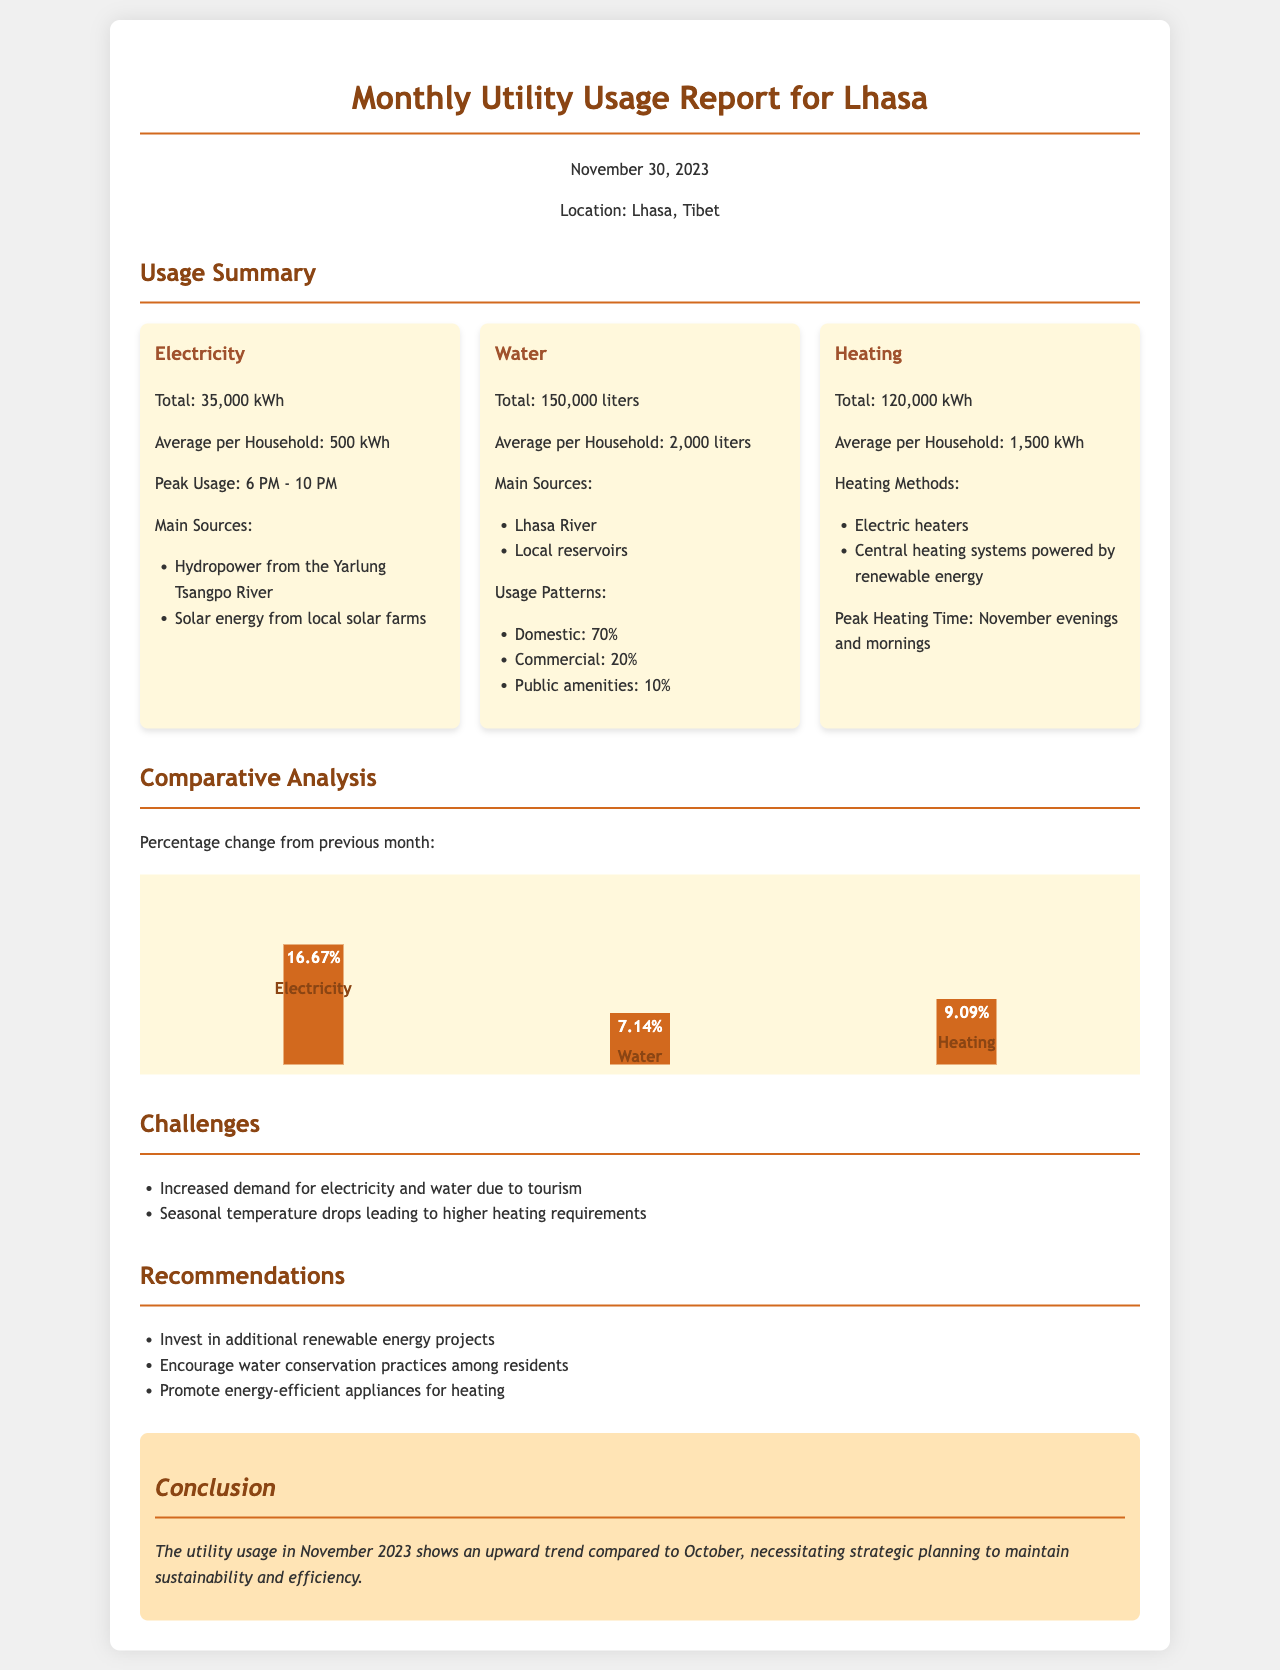what was the total electricity usage? The total electricity usage is specified in the document section on Electricity, totaling 35,000 kWh.
Answer: 35,000 kWh what is the average water consumption per household? The average water consumption per household is outlined in the Water section as 2,000 liters.
Answer: 2,000 liters which energy source was highlighted as a main source for electricity? The document mentions two main sources for electricity, one of which is hydropower from the Yarlung Tsangpo River.
Answer: Hydropower from the Yarlung Tsangpo River what percentage did electricity usage increase from the previous month? The document indicates that electricity usage increased by 16.67% compared to the previous month.
Answer: 16.67% what was the total heating consumption for November? The total heating consumption is stated in the document under Heating as 120,000 kWh.
Answer: 120,000 kWh what challenges are mentioned regarding utility usage? The document lists two main challenges, one being increased demand due to tourism.
Answer: Increased demand for electricity and water due to tourism how does November’s total water usage compare to October? To answer this, we look at the percentage increase, which is specified as 7.14%.
Answer: 7.14% what heating methods are mentioned in the report? The document describes two heating methods: electric heaters and central heating systems powered by renewable energy.
Answer: Electric heaters and central heating systems powered by renewable energy 